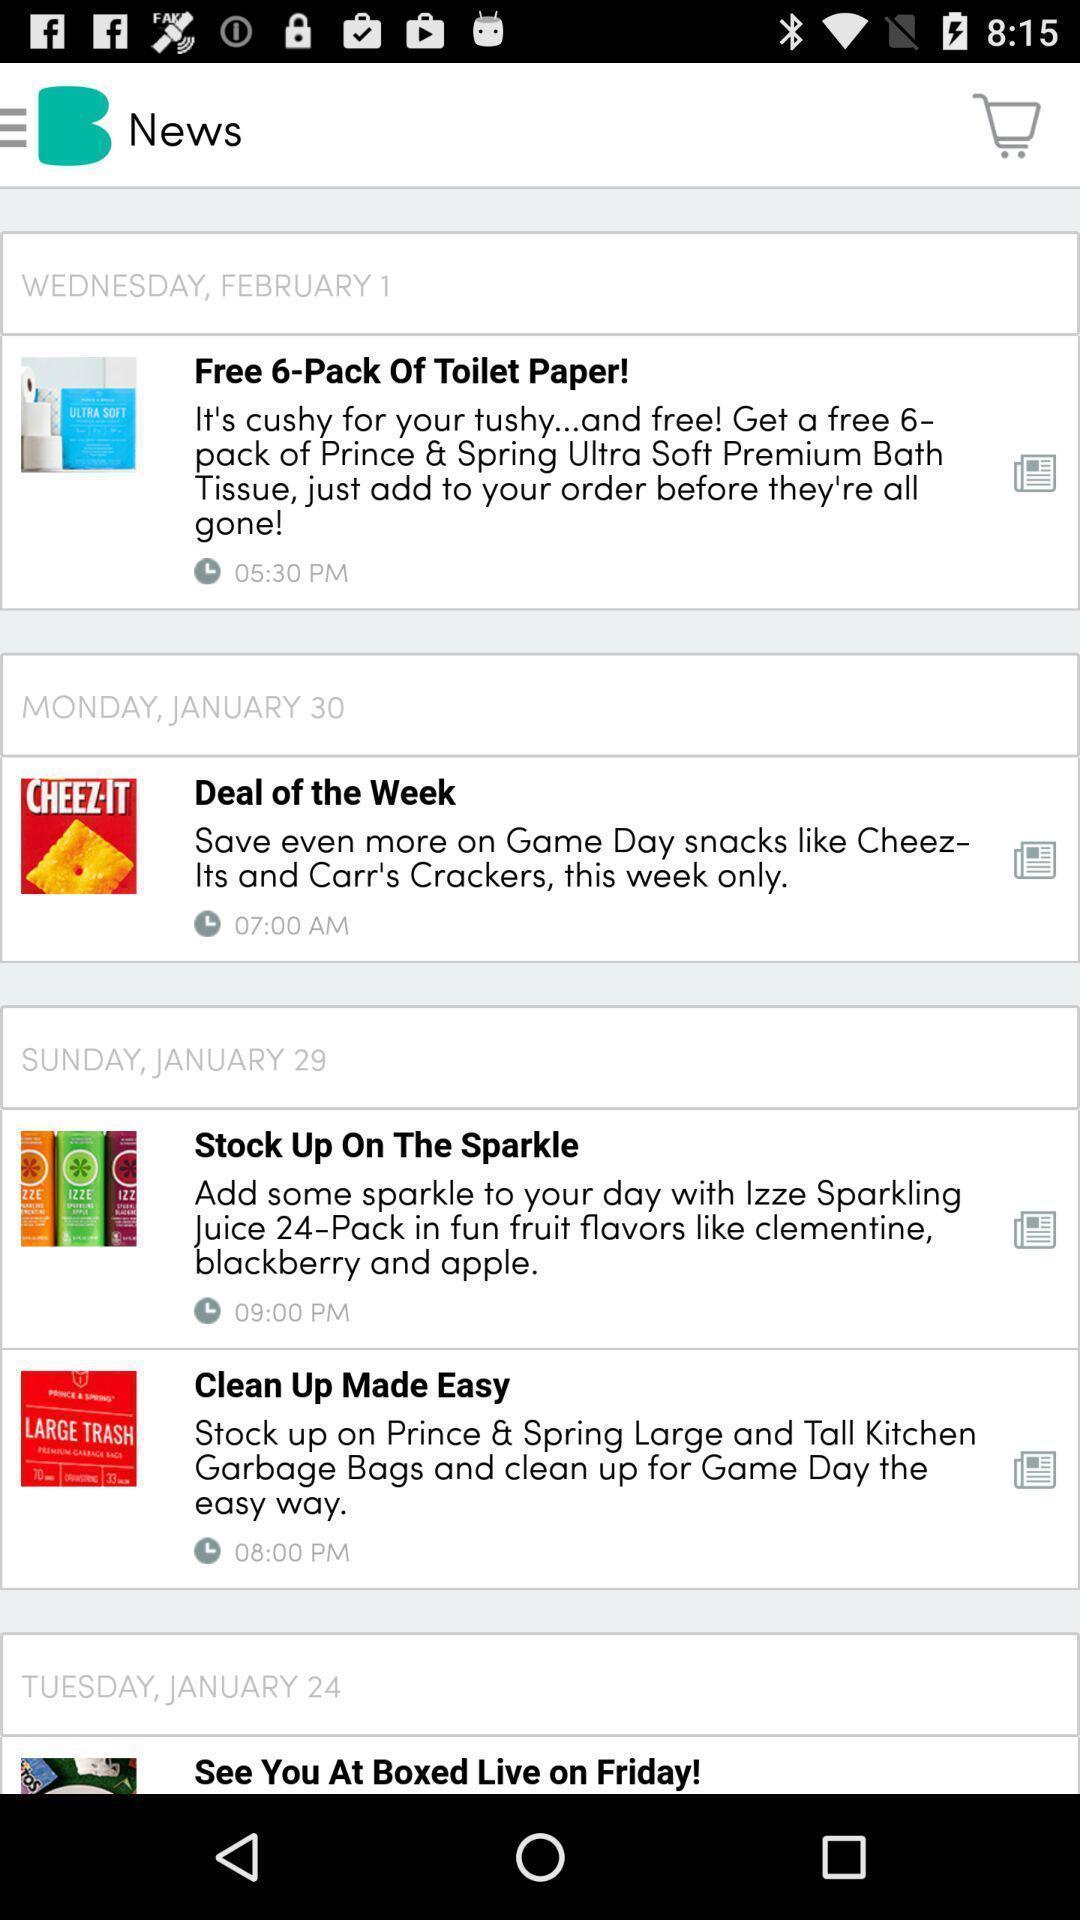Please provide a description for this image. Window displaying articles for shopping. 